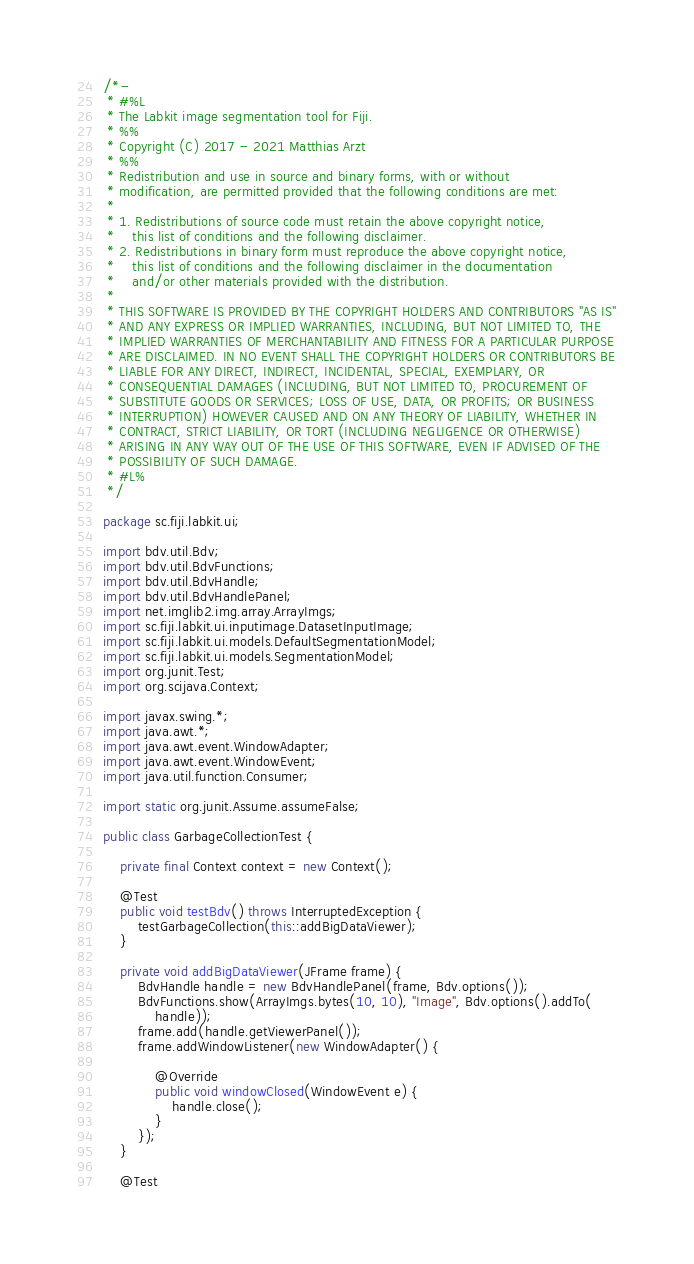Convert code to text. <code><loc_0><loc_0><loc_500><loc_500><_Java_>/*-
 * #%L
 * The Labkit image segmentation tool for Fiji.
 * %%
 * Copyright (C) 2017 - 2021 Matthias Arzt
 * %%
 * Redistribution and use in source and binary forms, with or without
 * modification, are permitted provided that the following conditions are met:
 * 
 * 1. Redistributions of source code must retain the above copyright notice,
 *    this list of conditions and the following disclaimer.
 * 2. Redistributions in binary form must reproduce the above copyright notice,
 *    this list of conditions and the following disclaimer in the documentation
 *    and/or other materials provided with the distribution.
 * 
 * THIS SOFTWARE IS PROVIDED BY THE COPYRIGHT HOLDERS AND CONTRIBUTORS "AS IS"
 * AND ANY EXPRESS OR IMPLIED WARRANTIES, INCLUDING, BUT NOT LIMITED TO, THE
 * IMPLIED WARRANTIES OF MERCHANTABILITY AND FITNESS FOR A PARTICULAR PURPOSE
 * ARE DISCLAIMED. IN NO EVENT SHALL THE COPYRIGHT HOLDERS OR CONTRIBUTORS BE
 * LIABLE FOR ANY DIRECT, INDIRECT, INCIDENTAL, SPECIAL, EXEMPLARY, OR
 * CONSEQUENTIAL DAMAGES (INCLUDING, BUT NOT LIMITED TO, PROCUREMENT OF
 * SUBSTITUTE GOODS OR SERVICES; LOSS OF USE, DATA, OR PROFITS; OR BUSINESS
 * INTERRUPTION) HOWEVER CAUSED AND ON ANY THEORY OF LIABILITY, WHETHER IN
 * CONTRACT, STRICT LIABILITY, OR TORT (INCLUDING NEGLIGENCE OR OTHERWISE)
 * ARISING IN ANY WAY OUT OF THE USE OF THIS SOFTWARE, EVEN IF ADVISED OF THE
 * POSSIBILITY OF SUCH DAMAGE.
 * #L%
 */

package sc.fiji.labkit.ui;

import bdv.util.Bdv;
import bdv.util.BdvFunctions;
import bdv.util.BdvHandle;
import bdv.util.BdvHandlePanel;
import net.imglib2.img.array.ArrayImgs;
import sc.fiji.labkit.ui.inputimage.DatasetInputImage;
import sc.fiji.labkit.ui.models.DefaultSegmentationModel;
import sc.fiji.labkit.ui.models.SegmentationModel;
import org.junit.Test;
import org.scijava.Context;

import javax.swing.*;
import java.awt.*;
import java.awt.event.WindowAdapter;
import java.awt.event.WindowEvent;
import java.util.function.Consumer;

import static org.junit.Assume.assumeFalse;

public class GarbageCollectionTest {

	private final Context context = new Context();

	@Test
	public void testBdv() throws InterruptedException {
		testGarbageCollection(this::addBigDataViewer);
	}

	private void addBigDataViewer(JFrame frame) {
		BdvHandle handle = new BdvHandlePanel(frame, Bdv.options());
		BdvFunctions.show(ArrayImgs.bytes(10, 10), "Image", Bdv.options().addTo(
			handle));
		frame.add(handle.getViewerPanel());
		frame.addWindowListener(new WindowAdapter() {

			@Override
			public void windowClosed(WindowEvent e) {
				handle.close();
			}
		});
	}

	@Test</code> 